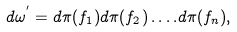Convert formula to latex. <formula><loc_0><loc_0><loc_500><loc_500>d \omega ^ { ^ { \prime } } = d \pi ( f _ { 1 } ) d \pi ( f _ { 2 } ) \dots . d \pi ( f _ { n } ) ,</formula> 